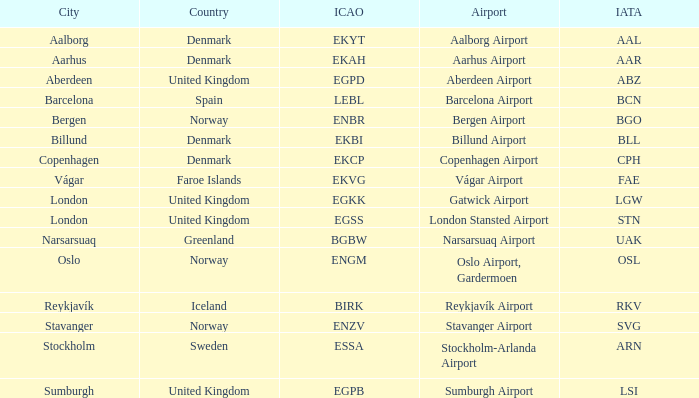What airport has an ICAP of BGBW? Narsarsuaq Airport. 